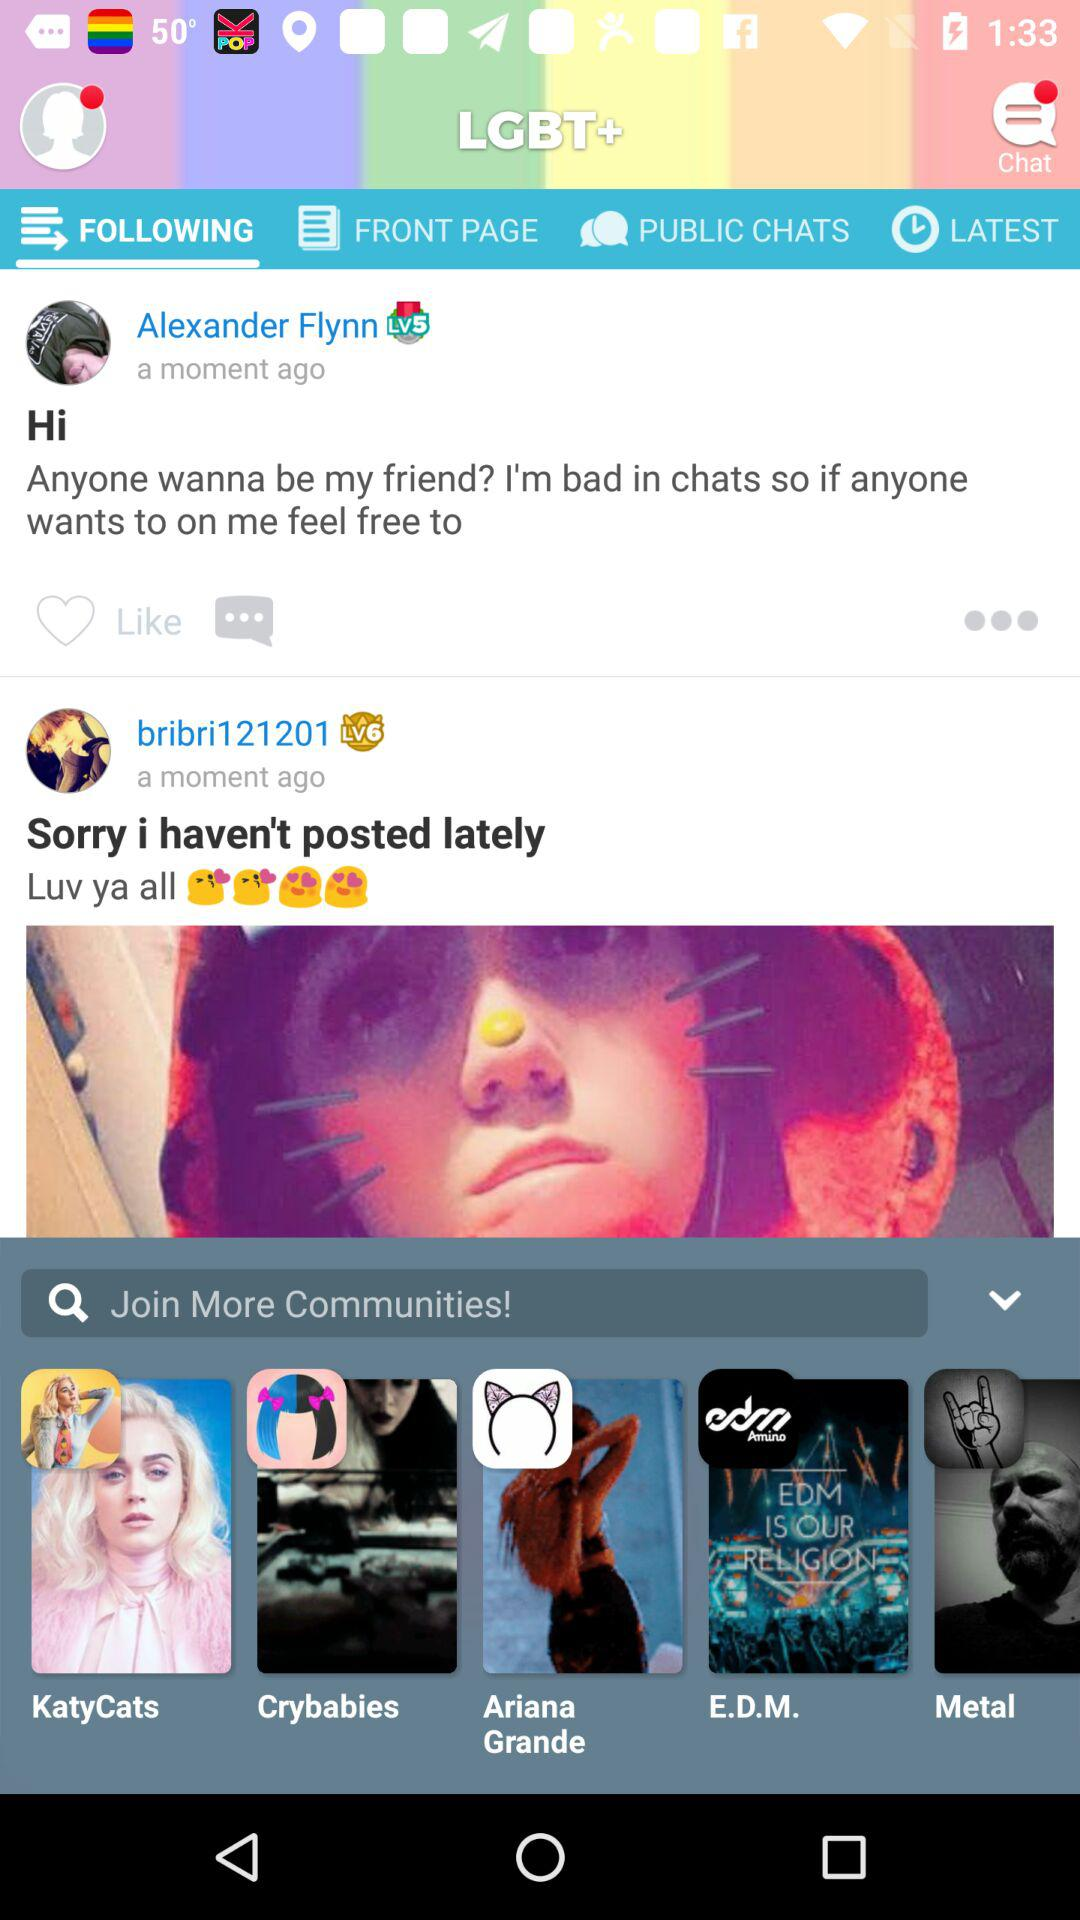Which tab is selected? The selected tab is "FOLLOWING". 